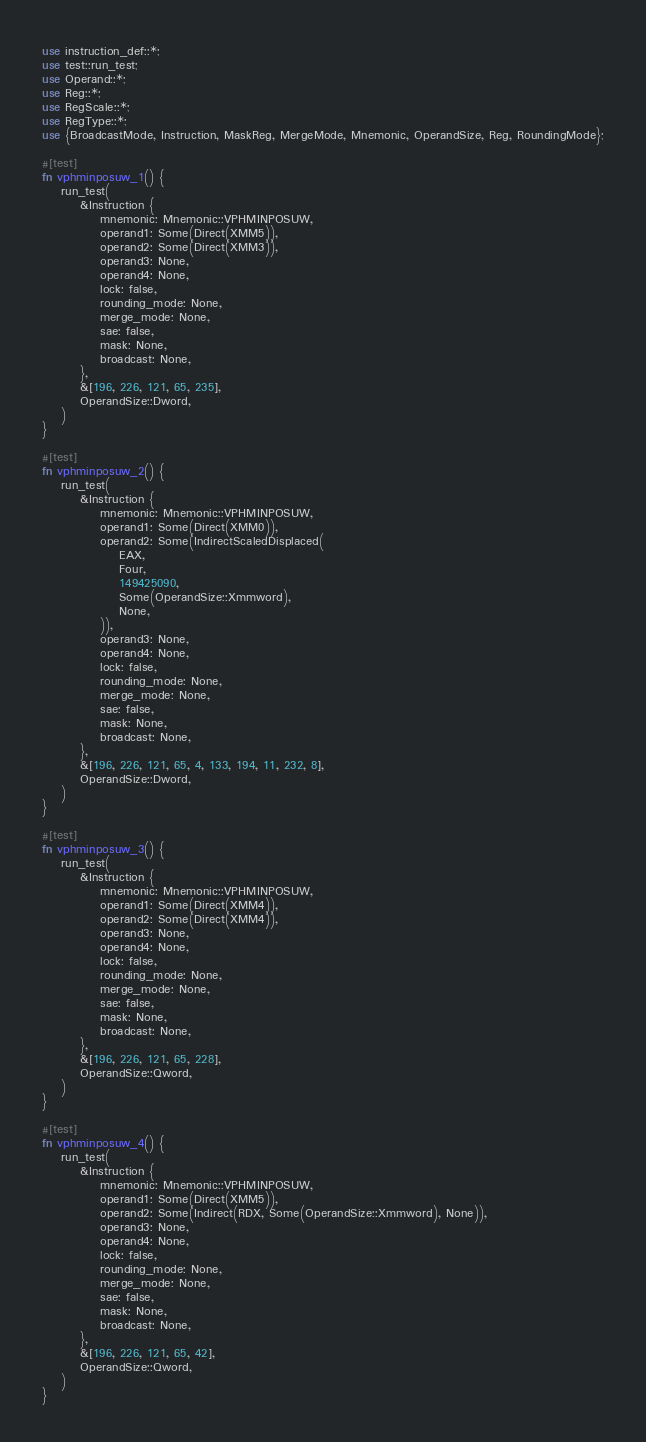Convert code to text. <code><loc_0><loc_0><loc_500><loc_500><_Rust_>use instruction_def::*;
use test::run_test;
use Operand::*;
use Reg::*;
use RegScale::*;
use RegType::*;
use {BroadcastMode, Instruction, MaskReg, MergeMode, Mnemonic, OperandSize, Reg, RoundingMode};

#[test]
fn vphminposuw_1() {
    run_test(
        &Instruction {
            mnemonic: Mnemonic::VPHMINPOSUW,
            operand1: Some(Direct(XMM5)),
            operand2: Some(Direct(XMM3)),
            operand3: None,
            operand4: None,
            lock: false,
            rounding_mode: None,
            merge_mode: None,
            sae: false,
            mask: None,
            broadcast: None,
        },
        &[196, 226, 121, 65, 235],
        OperandSize::Dword,
    )
}

#[test]
fn vphminposuw_2() {
    run_test(
        &Instruction {
            mnemonic: Mnemonic::VPHMINPOSUW,
            operand1: Some(Direct(XMM0)),
            operand2: Some(IndirectScaledDisplaced(
                EAX,
                Four,
                149425090,
                Some(OperandSize::Xmmword),
                None,
            )),
            operand3: None,
            operand4: None,
            lock: false,
            rounding_mode: None,
            merge_mode: None,
            sae: false,
            mask: None,
            broadcast: None,
        },
        &[196, 226, 121, 65, 4, 133, 194, 11, 232, 8],
        OperandSize::Dword,
    )
}

#[test]
fn vphminposuw_3() {
    run_test(
        &Instruction {
            mnemonic: Mnemonic::VPHMINPOSUW,
            operand1: Some(Direct(XMM4)),
            operand2: Some(Direct(XMM4)),
            operand3: None,
            operand4: None,
            lock: false,
            rounding_mode: None,
            merge_mode: None,
            sae: false,
            mask: None,
            broadcast: None,
        },
        &[196, 226, 121, 65, 228],
        OperandSize::Qword,
    )
}

#[test]
fn vphminposuw_4() {
    run_test(
        &Instruction {
            mnemonic: Mnemonic::VPHMINPOSUW,
            operand1: Some(Direct(XMM5)),
            operand2: Some(Indirect(RDX, Some(OperandSize::Xmmword), None)),
            operand3: None,
            operand4: None,
            lock: false,
            rounding_mode: None,
            merge_mode: None,
            sae: false,
            mask: None,
            broadcast: None,
        },
        &[196, 226, 121, 65, 42],
        OperandSize::Qword,
    )
}
</code> 